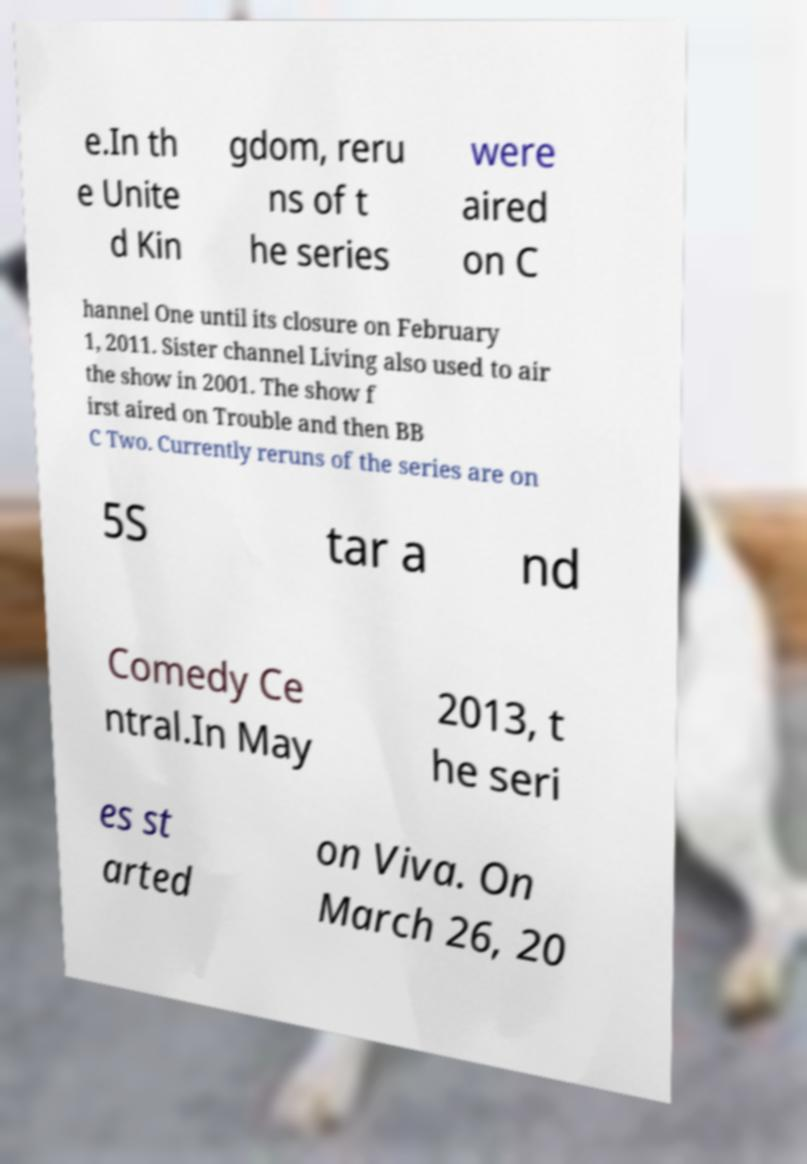Can you accurately transcribe the text from the provided image for me? e.In th e Unite d Kin gdom, reru ns of t he series were aired on C hannel One until its closure on February 1, 2011. Sister channel Living also used to air the show in 2001. The show f irst aired on Trouble and then BB C Two. Currently reruns of the series are on 5S tar a nd Comedy Ce ntral.In May 2013, t he seri es st arted on Viva. On March 26, 20 